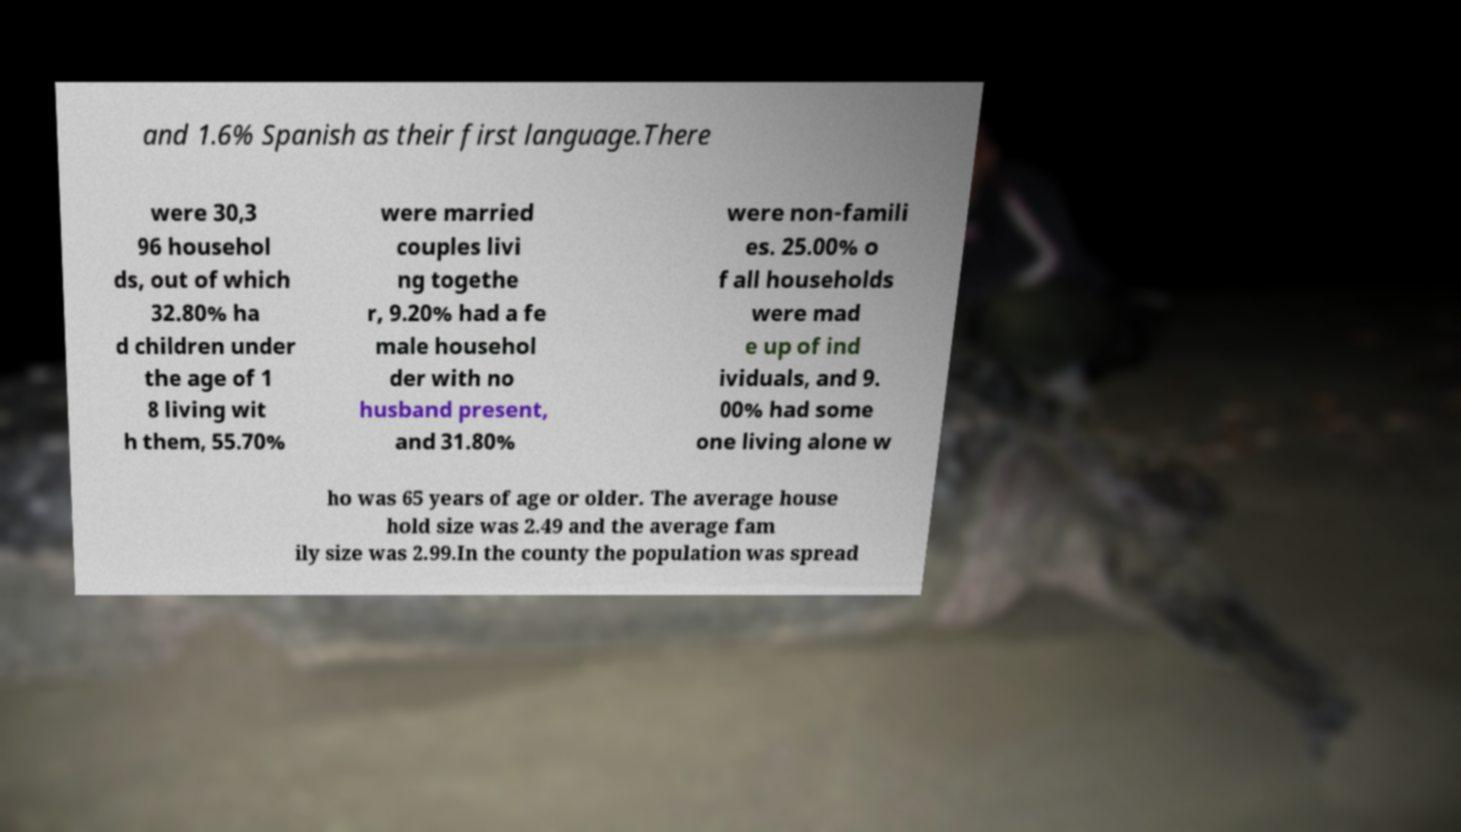Could you extract and type out the text from this image? and 1.6% Spanish as their first language.There were 30,3 96 househol ds, out of which 32.80% ha d children under the age of 1 8 living wit h them, 55.70% were married couples livi ng togethe r, 9.20% had a fe male househol der with no husband present, and 31.80% were non-famili es. 25.00% o f all households were mad e up of ind ividuals, and 9. 00% had some one living alone w ho was 65 years of age or older. The average house hold size was 2.49 and the average fam ily size was 2.99.In the county the population was spread 